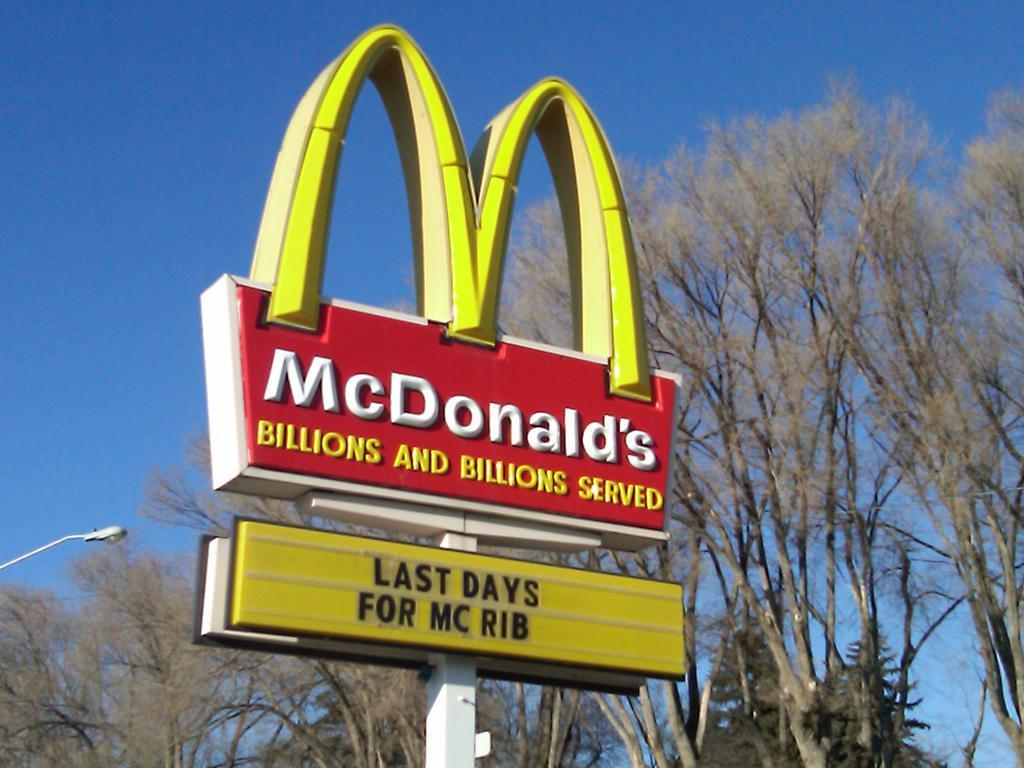Please provide a concise description of this image. In the foreground of the picture we can see the board of McDonald's. In the middle we can see trees and a street light. In the background there is sky. 